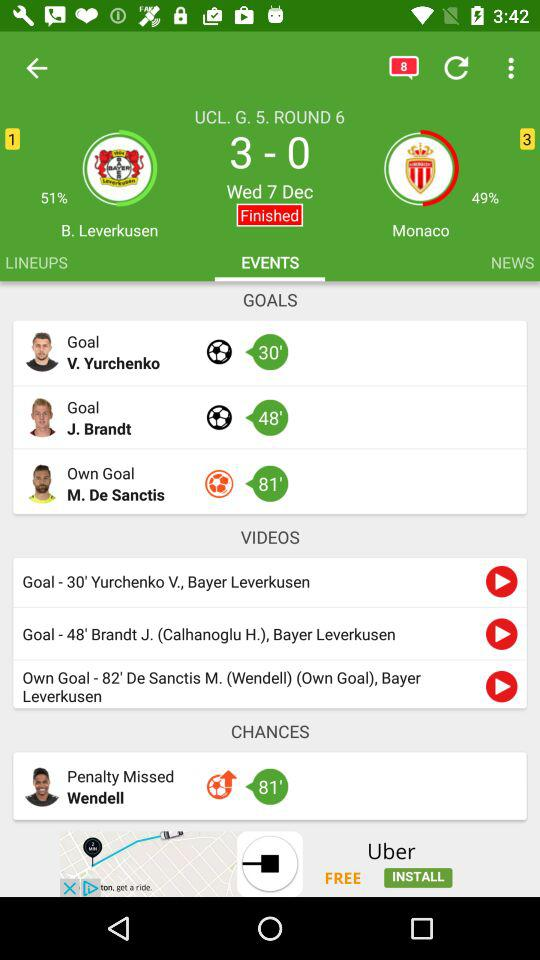How many goals did Leverkusen score?
Answer the question using a single word or phrase. 3 